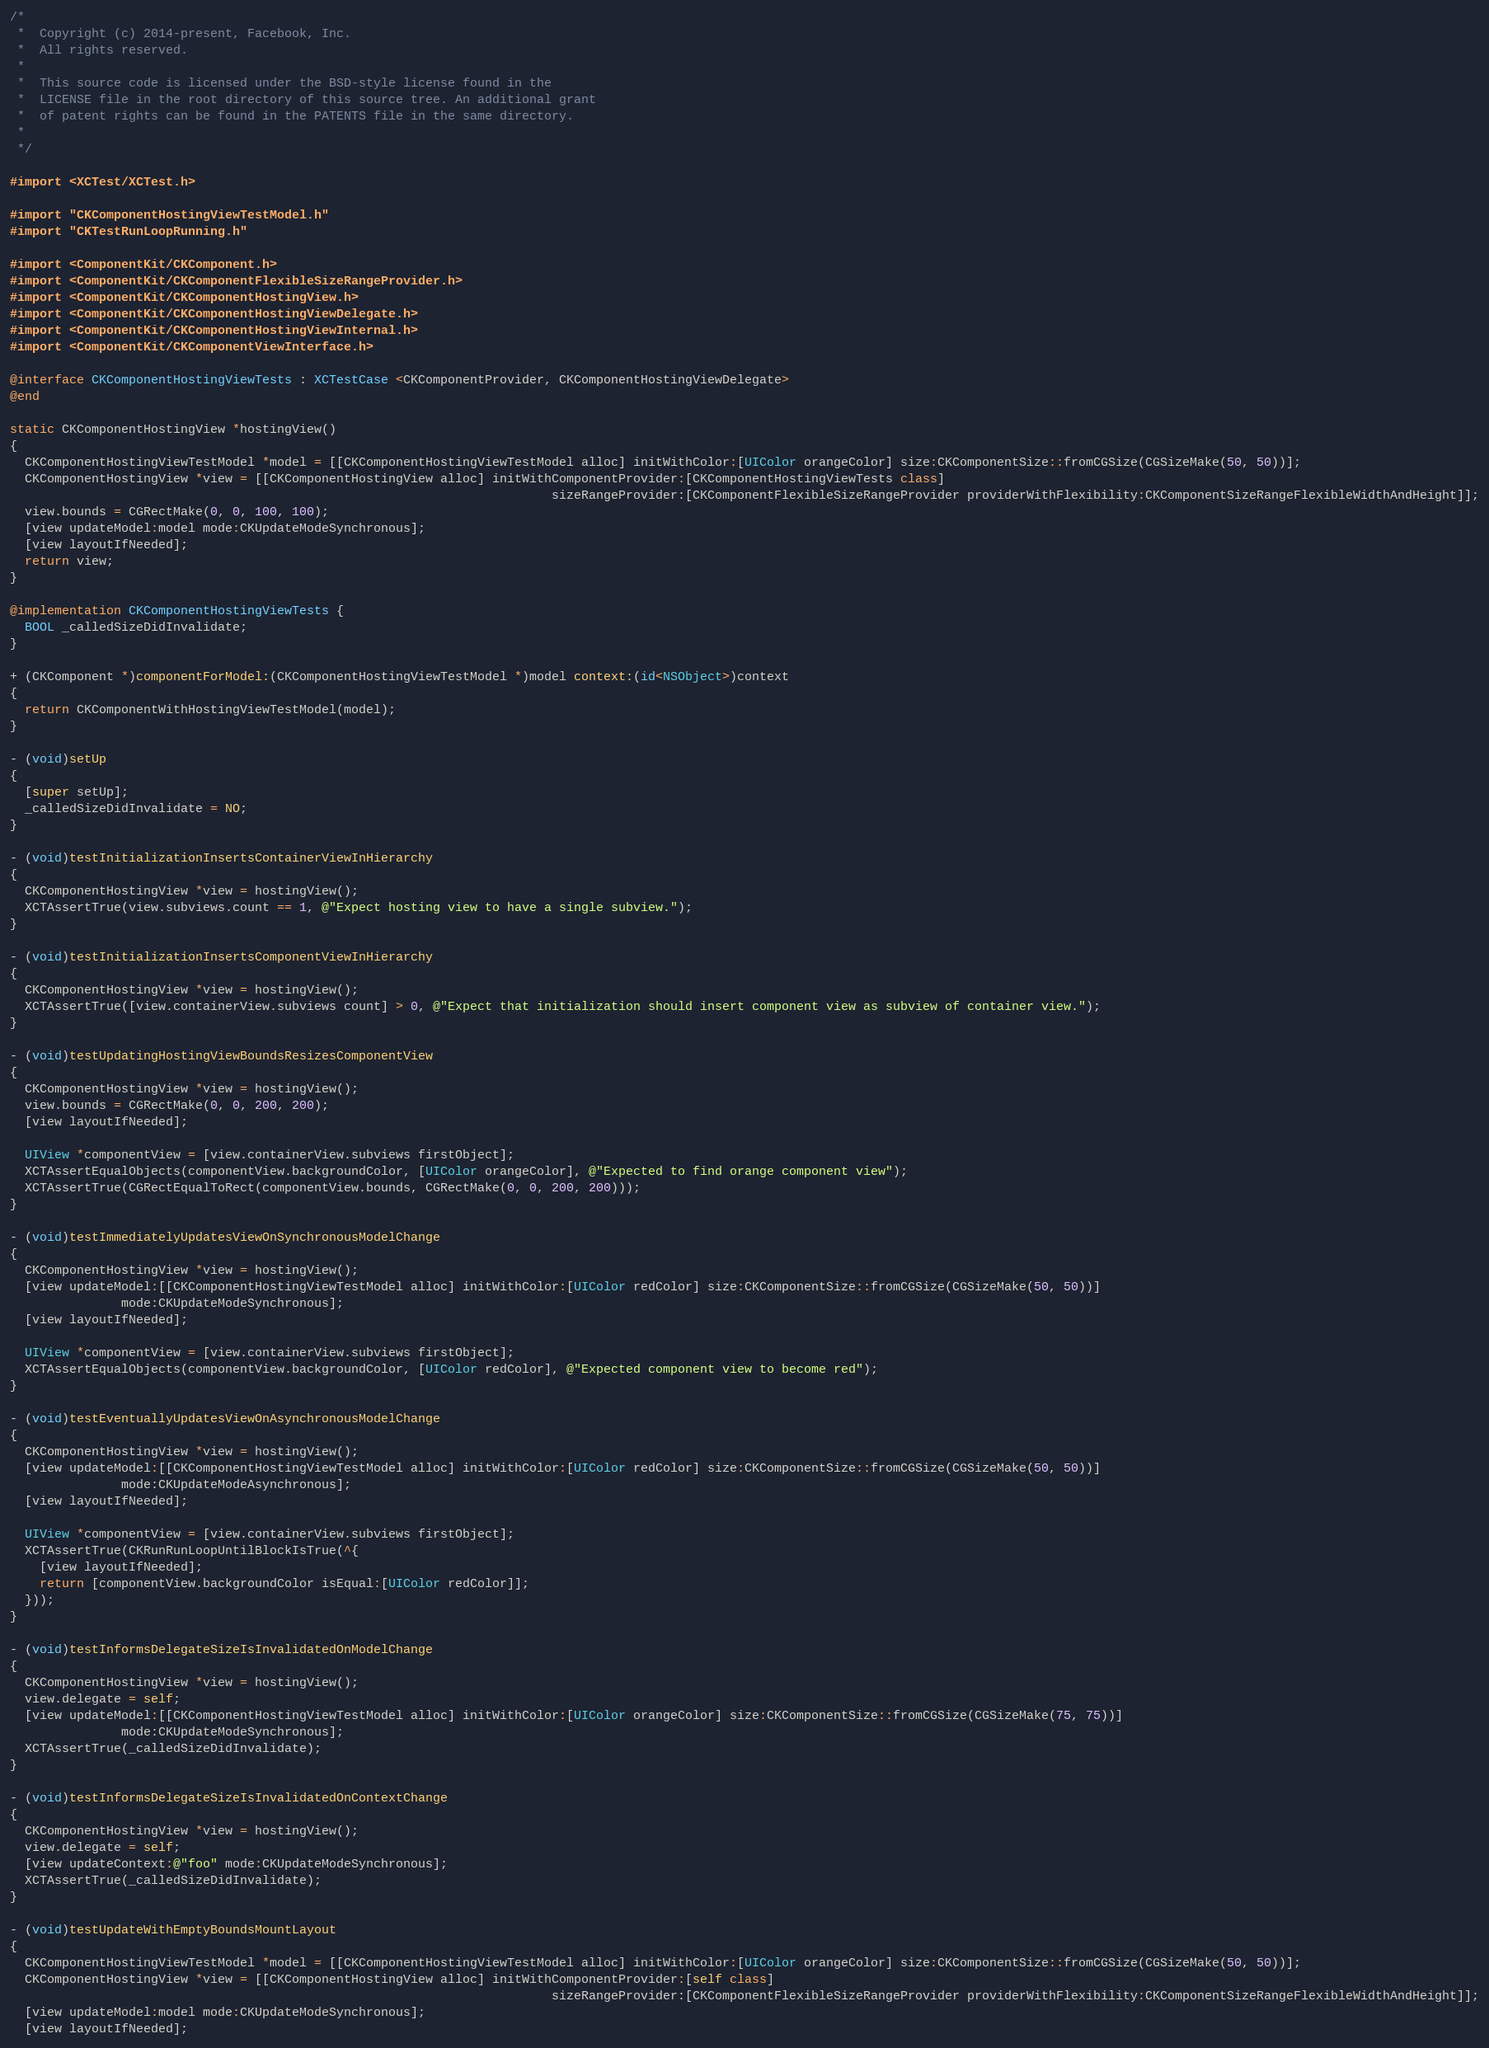<code> <loc_0><loc_0><loc_500><loc_500><_ObjectiveC_>/*
 *  Copyright (c) 2014-present, Facebook, Inc.
 *  All rights reserved.
 *
 *  This source code is licensed under the BSD-style license found in the
 *  LICENSE file in the root directory of this source tree. An additional grant
 *  of patent rights can be found in the PATENTS file in the same directory.
 *
 */

#import <XCTest/XCTest.h>

#import "CKComponentHostingViewTestModel.h"
#import "CKTestRunLoopRunning.h"

#import <ComponentKit/CKComponent.h>
#import <ComponentKit/CKComponentFlexibleSizeRangeProvider.h>
#import <ComponentKit/CKComponentHostingView.h>
#import <ComponentKit/CKComponentHostingViewDelegate.h>
#import <ComponentKit/CKComponentHostingViewInternal.h>
#import <ComponentKit/CKComponentViewInterface.h>

@interface CKComponentHostingViewTests : XCTestCase <CKComponentProvider, CKComponentHostingViewDelegate>
@end

static CKComponentHostingView *hostingView()
{
  CKComponentHostingViewTestModel *model = [[CKComponentHostingViewTestModel alloc] initWithColor:[UIColor orangeColor] size:CKComponentSize::fromCGSize(CGSizeMake(50, 50))];
  CKComponentHostingView *view = [[CKComponentHostingView alloc] initWithComponentProvider:[CKComponentHostingViewTests class]
                                                                         sizeRangeProvider:[CKComponentFlexibleSizeRangeProvider providerWithFlexibility:CKComponentSizeRangeFlexibleWidthAndHeight]];
  view.bounds = CGRectMake(0, 0, 100, 100);
  [view updateModel:model mode:CKUpdateModeSynchronous];
  [view layoutIfNeeded];
  return view;
}

@implementation CKComponentHostingViewTests {
  BOOL _calledSizeDidInvalidate;
}

+ (CKComponent *)componentForModel:(CKComponentHostingViewTestModel *)model context:(id<NSObject>)context
{
  return CKComponentWithHostingViewTestModel(model);
}

- (void)setUp
{
  [super setUp];
  _calledSizeDidInvalidate = NO;
}

- (void)testInitializationInsertsContainerViewInHierarchy
{
  CKComponentHostingView *view = hostingView();
  XCTAssertTrue(view.subviews.count == 1, @"Expect hosting view to have a single subview.");
}

- (void)testInitializationInsertsComponentViewInHierarchy
{
  CKComponentHostingView *view = hostingView();
  XCTAssertTrue([view.containerView.subviews count] > 0, @"Expect that initialization should insert component view as subview of container view.");
}

- (void)testUpdatingHostingViewBoundsResizesComponentView
{
  CKComponentHostingView *view = hostingView();
  view.bounds = CGRectMake(0, 0, 200, 200);
  [view layoutIfNeeded];

  UIView *componentView = [view.containerView.subviews firstObject];
  XCTAssertEqualObjects(componentView.backgroundColor, [UIColor orangeColor], @"Expected to find orange component view");
  XCTAssertTrue(CGRectEqualToRect(componentView.bounds, CGRectMake(0, 0, 200, 200)));
}

- (void)testImmediatelyUpdatesViewOnSynchronousModelChange
{
  CKComponentHostingView *view = hostingView();
  [view updateModel:[[CKComponentHostingViewTestModel alloc] initWithColor:[UIColor redColor] size:CKComponentSize::fromCGSize(CGSizeMake(50, 50))]
               mode:CKUpdateModeSynchronous];
  [view layoutIfNeeded];

  UIView *componentView = [view.containerView.subviews firstObject];
  XCTAssertEqualObjects(componentView.backgroundColor, [UIColor redColor], @"Expected component view to become red");
}

- (void)testEventuallyUpdatesViewOnAsynchronousModelChange
{
  CKComponentHostingView *view = hostingView();
  [view updateModel:[[CKComponentHostingViewTestModel alloc] initWithColor:[UIColor redColor] size:CKComponentSize::fromCGSize(CGSizeMake(50, 50))]
               mode:CKUpdateModeAsynchronous];
  [view layoutIfNeeded];

  UIView *componentView = [view.containerView.subviews firstObject];
  XCTAssertTrue(CKRunRunLoopUntilBlockIsTrue(^{
    [view layoutIfNeeded];
    return [componentView.backgroundColor isEqual:[UIColor redColor]];
  }));
}

- (void)testInformsDelegateSizeIsInvalidatedOnModelChange
{
  CKComponentHostingView *view = hostingView();
  view.delegate = self;
  [view updateModel:[[CKComponentHostingViewTestModel alloc] initWithColor:[UIColor orangeColor] size:CKComponentSize::fromCGSize(CGSizeMake(75, 75))]
               mode:CKUpdateModeSynchronous];
  XCTAssertTrue(_calledSizeDidInvalidate);
}

- (void)testInformsDelegateSizeIsInvalidatedOnContextChange
{
  CKComponentHostingView *view = hostingView();
  view.delegate = self;
  [view updateContext:@"foo" mode:CKUpdateModeSynchronous];
  XCTAssertTrue(_calledSizeDidInvalidate);
}

- (void)testUpdateWithEmptyBoundsMountLayout
{
  CKComponentHostingViewTestModel *model = [[CKComponentHostingViewTestModel alloc] initWithColor:[UIColor orangeColor] size:CKComponentSize::fromCGSize(CGSizeMake(50, 50))];
  CKComponentHostingView *view = [[CKComponentHostingView alloc] initWithComponentProvider:[self class]
                                                                         sizeRangeProvider:[CKComponentFlexibleSizeRangeProvider providerWithFlexibility:CKComponentSizeRangeFlexibleWidthAndHeight]];
  [view updateModel:model mode:CKUpdateModeSynchronous];
  [view layoutIfNeeded];
</code> 